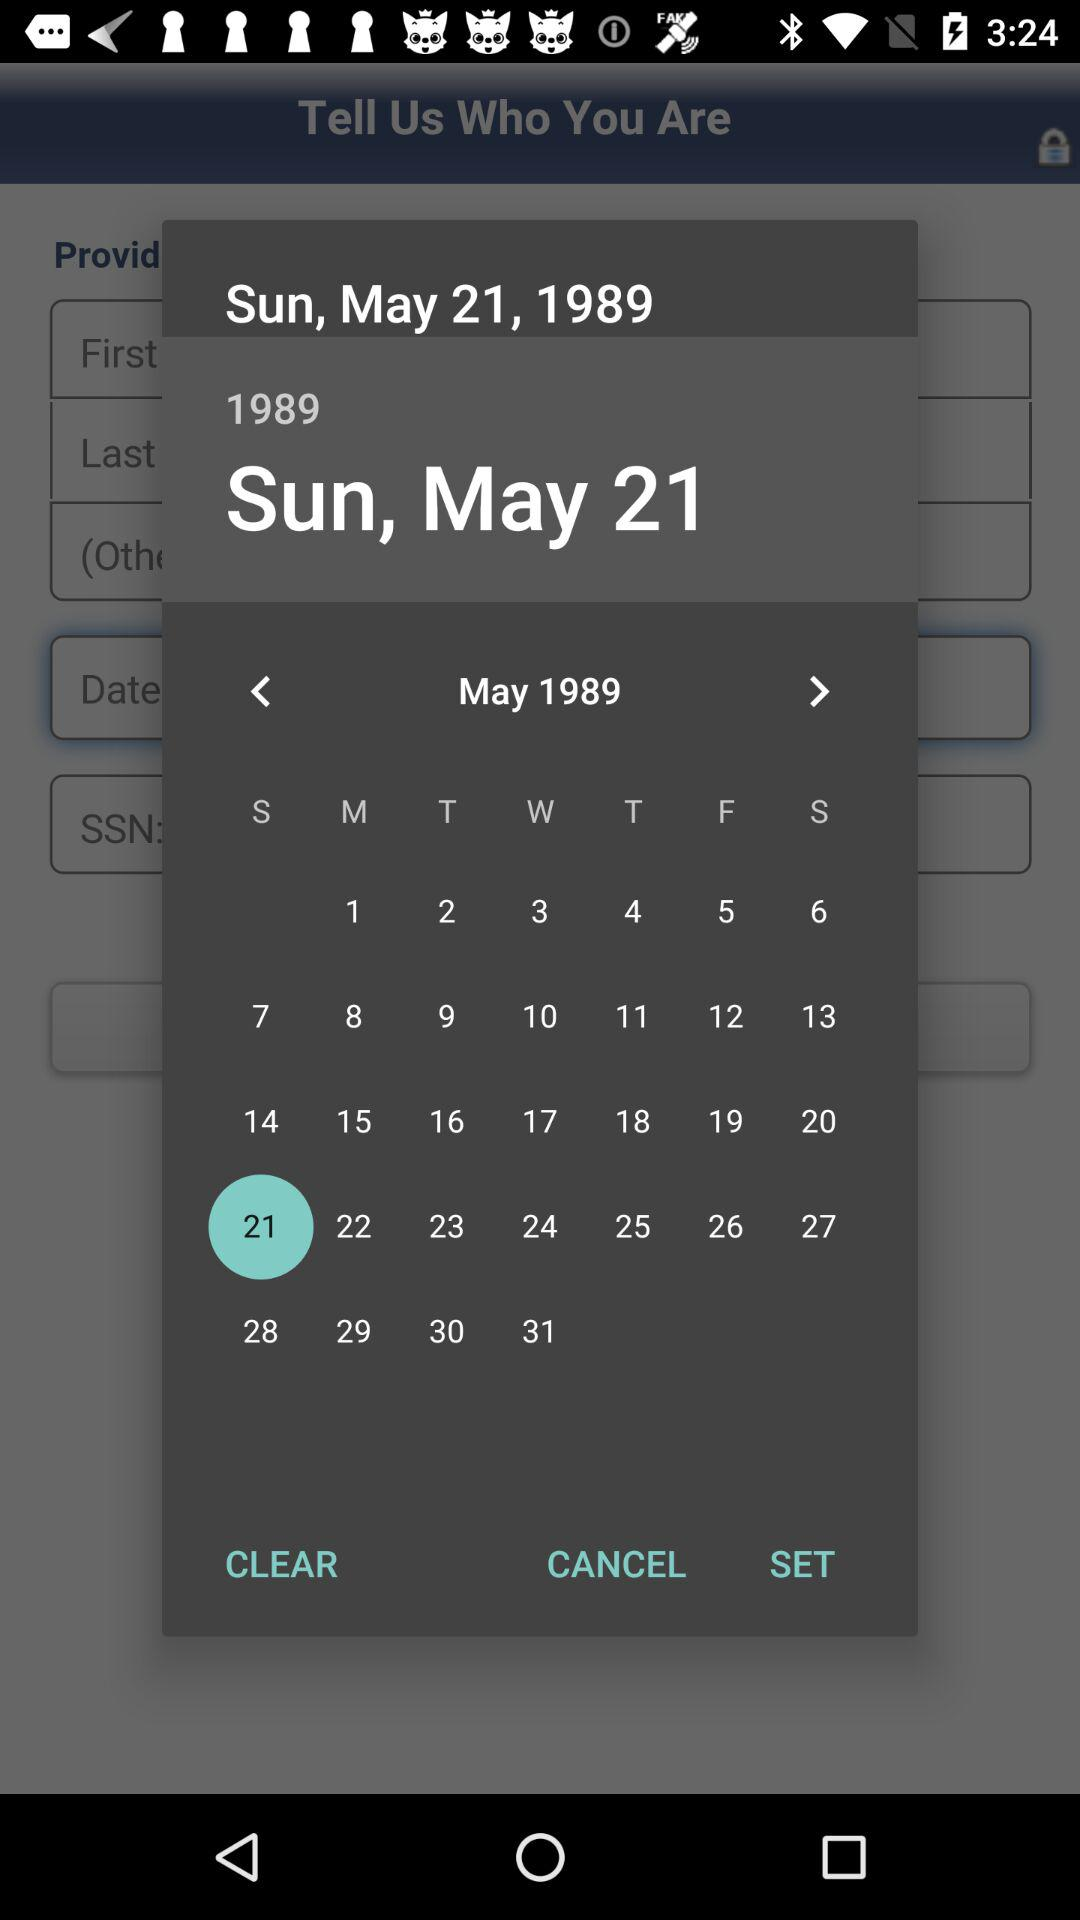What date is selected? The selected date is Sunday, May 21, 1989. 